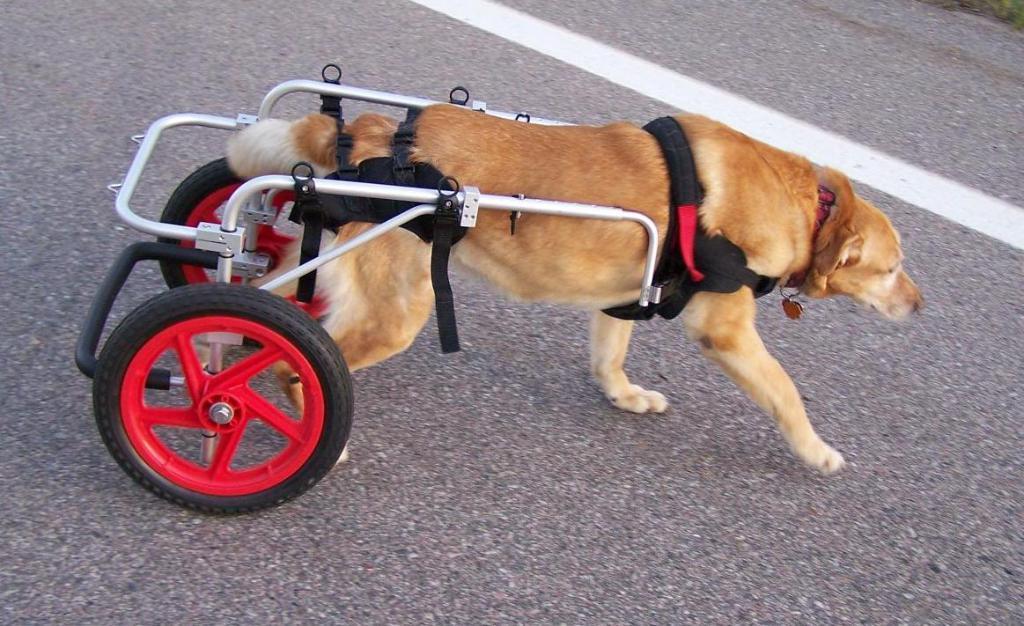How would you summarize this image in a sentence or two? Here in this picture we can see a dog present on a road over there and behind it we can see two wheels which are connected to it present over there. 